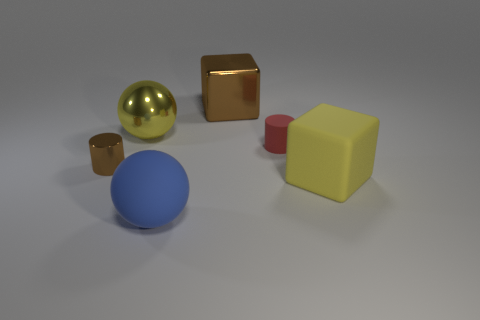How many small rubber cylinders are on the left side of the shiny cylinder that is left of the yellow metallic ball?
Keep it short and to the point. 0. There is a large yellow thing that is behind the tiny red thing; does it have the same shape as the big rubber object that is to the left of the large rubber cube?
Your answer should be very brief. Yes. How many things are in front of the brown metal cube and behind the rubber sphere?
Offer a terse response. 4. Are there any tiny metallic cylinders that have the same color as the metal sphere?
Offer a very short reply. No. The blue rubber object that is the same size as the yellow sphere is what shape?
Give a very brief answer. Sphere. There is a big matte cube; are there any large shiny cubes right of it?
Your response must be concise. No. Do the brown object behind the red matte cylinder and the cube in front of the brown shiny cylinder have the same material?
Ensure brevity in your answer.  No. How many red shiny objects are the same size as the yellow rubber block?
Keep it short and to the point. 0. What shape is the other object that is the same color as the tiny shiny thing?
Keep it short and to the point. Cube. What material is the brown thing that is in front of the matte cylinder?
Give a very brief answer. Metal. 